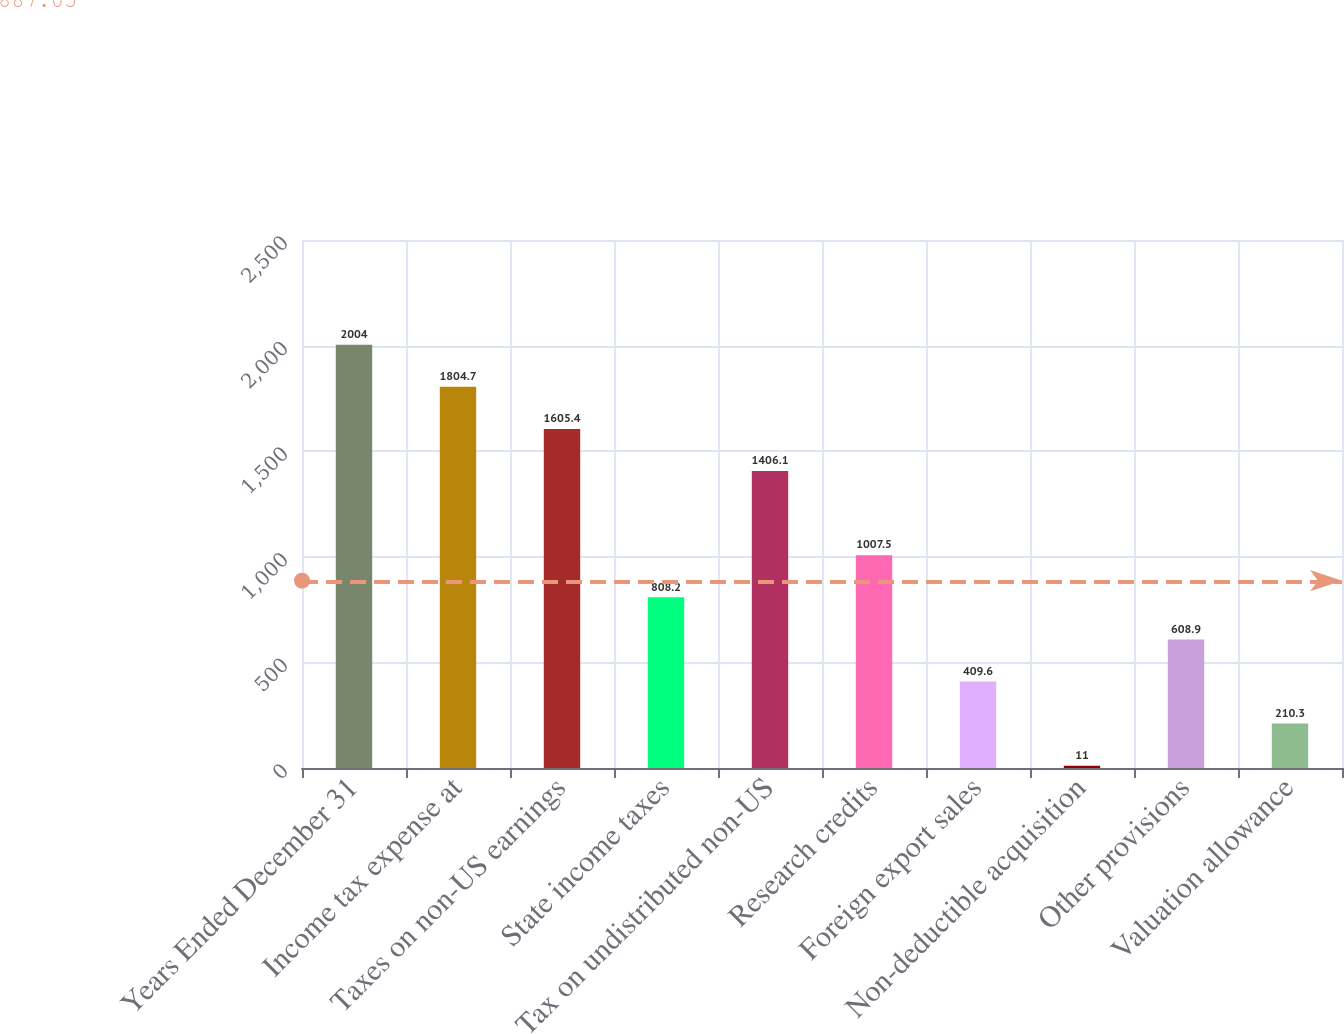<chart> <loc_0><loc_0><loc_500><loc_500><bar_chart><fcel>Years Ended December 31<fcel>Income tax expense at<fcel>Taxes on non-US earnings<fcel>State income taxes<fcel>Tax on undistributed non-US<fcel>Research credits<fcel>Foreign export sales<fcel>Non-deductible acquisition<fcel>Other provisions<fcel>Valuation allowance<nl><fcel>2004<fcel>1804.7<fcel>1605.4<fcel>808.2<fcel>1406.1<fcel>1007.5<fcel>409.6<fcel>11<fcel>608.9<fcel>210.3<nl></chart> 